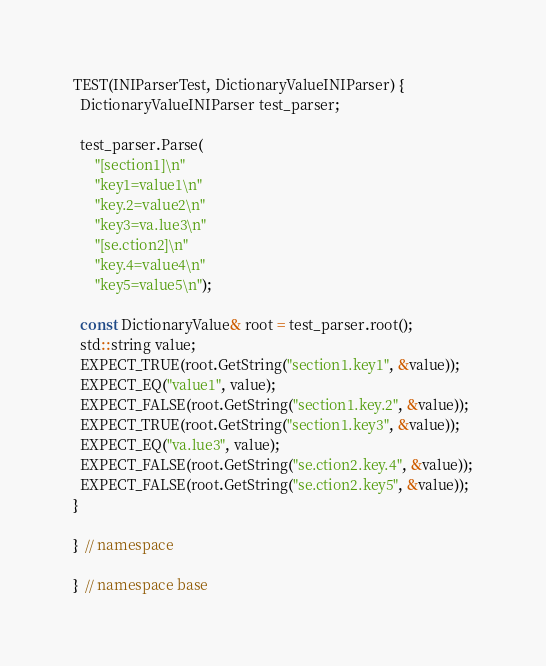Convert code to text. <code><loc_0><loc_0><loc_500><loc_500><_C++_>TEST(INIParserTest, DictionaryValueINIParser) {
  DictionaryValueINIParser test_parser;

  test_parser.Parse(
      "[section1]\n"
      "key1=value1\n"
      "key.2=value2\n"
      "key3=va.lue3\n"
      "[se.ction2]\n"
      "key.4=value4\n"
      "key5=value5\n");

  const DictionaryValue& root = test_parser.root();
  std::string value;
  EXPECT_TRUE(root.GetString("section1.key1", &value));
  EXPECT_EQ("value1", value);
  EXPECT_FALSE(root.GetString("section1.key.2", &value));
  EXPECT_TRUE(root.GetString("section1.key3", &value));
  EXPECT_EQ("va.lue3", value);
  EXPECT_FALSE(root.GetString("se.ction2.key.4", &value));
  EXPECT_FALSE(root.GetString("se.ction2.key5", &value));
}

}  // namespace

}  // namespace base
</code> 